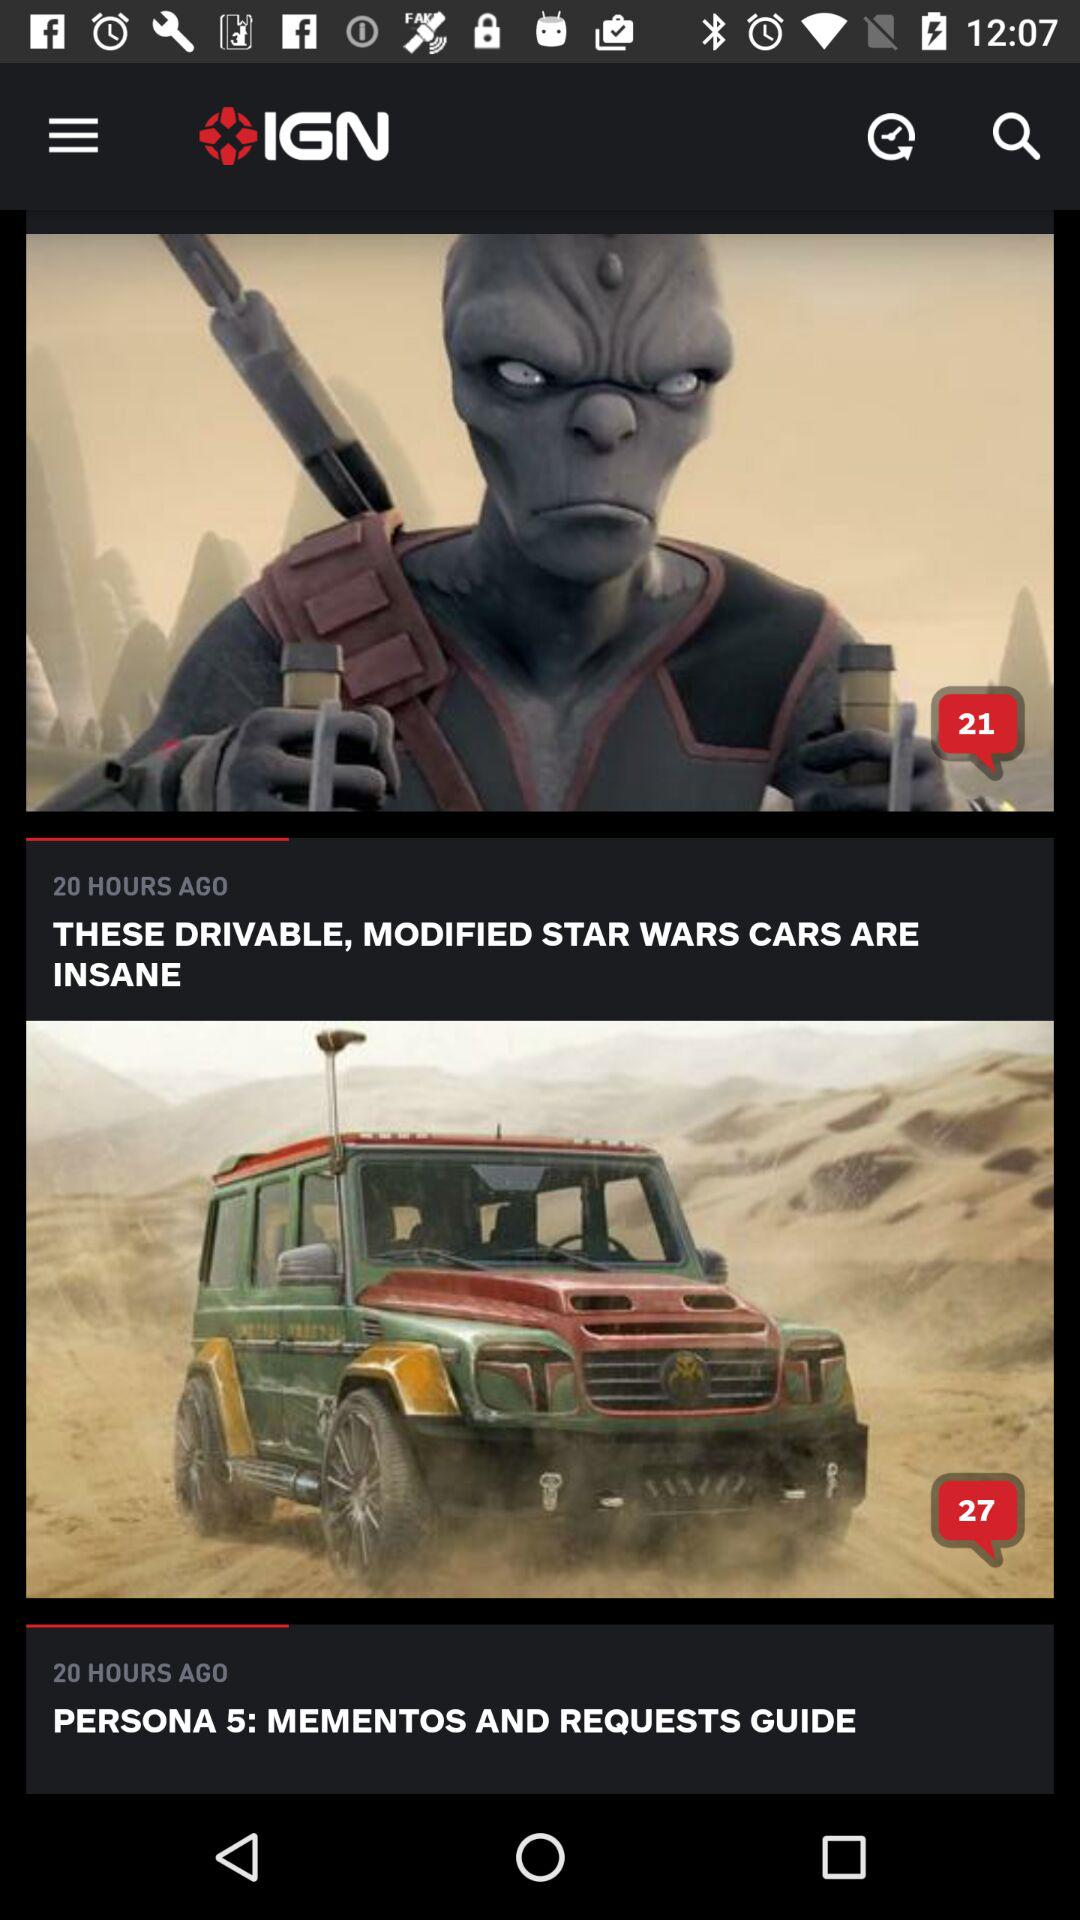When was "PERSONA 5" posted? "PERSONA 5" was posted 20 hours ago. 